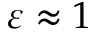Convert formula to latex. <formula><loc_0><loc_0><loc_500><loc_500>\varepsilon \approx 1</formula> 